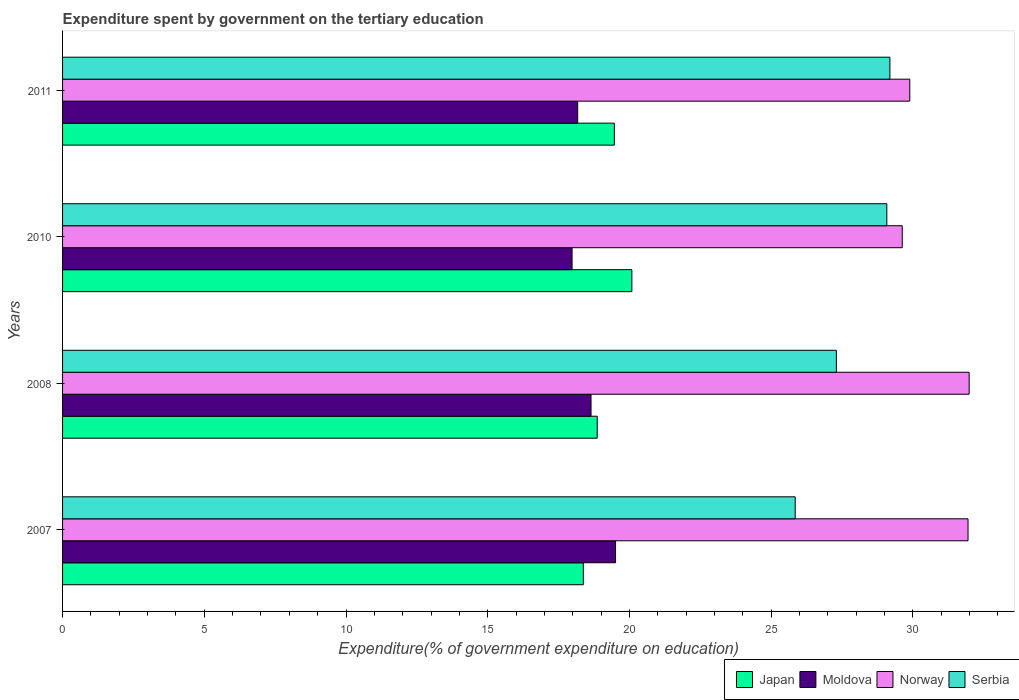How many different coloured bars are there?
Keep it short and to the point. 4. How many groups of bars are there?
Give a very brief answer. 4. Are the number of bars on each tick of the Y-axis equal?
Make the answer very short. Yes. In how many cases, is the number of bars for a given year not equal to the number of legend labels?
Your response must be concise. 0. What is the expenditure spent by government on the tertiary education in Norway in 2011?
Offer a very short reply. 29.89. Across all years, what is the maximum expenditure spent by government on the tertiary education in Norway?
Make the answer very short. 31.99. Across all years, what is the minimum expenditure spent by government on the tertiary education in Serbia?
Offer a very short reply. 25.85. In which year was the expenditure spent by government on the tertiary education in Moldova maximum?
Offer a terse response. 2007. In which year was the expenditure spent by government on the tertiary education in Japan minimum?
Your answer should be compact. 2007. What is the total expenditure spent by government on the tertiary education in Norway in the graph?
Keep it short and to the point. 123.45. What is the difference between the expenditure spent by government on the tertiary education in Norway in 2007 and that in 2010?
Keep it short and to the point. 2.32. What is the difference between the expenditure spent by government on the tertiary education in Moldova in 2011 and the expenditure spent by government on the tertiary education in Japan in 2008?
Your answer should be compact. -0.69. What is the average expenditure spent by government on the tertiary education in Norway per year?
Your response must be concise. 30.86. In the year 2010, what is the difference between the expenditure spent by government on the tertiary education in Japan and expenditure spent by government on the tertiary education in Serbia?
Your answer should be compact. -9. What is the ratio of the expenditure spent by government on the tertiary education in Serbia in 2007 to that in 2010?
Offer a very short reply. 0.89. Is the difference between the expenditure spent by government on the tertiary education in Japan in 2007 and 2011 greater than the difference between the expenditure spent by government on the tertiary education in Serbia in 2007 and 2011?
Offer a very short reply. Yes. What is the difference between the highest and the second highest expenditure spent by government on the tertiary education in Serbia?
Offer a terse response. 0.11. What is the difference between the highest and the lowest expenditure spent by government on the tertiary education in Norway?
Provide a short and direct response. 2.36. Is the sum of the expenditure spent by government on the tertiary education in Norway in 2008 and 2011 greater than the maximum expenditure spent by government on the tertiary education in Serbia across all years?
Give a very brief answer. Yes. Is it the case that in every year, the sum of the expenditure spent by government on the tertiary education in Serbia and expenditure spent by government on the tertiary education in Moldova is greater than the sum of expenditure spent by government on the tertiary education in Japan and expenditure spent by government on the tertiary education in Norway?
Offer a very short reply. No. What does the 2nd bar from the top in 2010 represents?
Offer a very short reply. Norway. Is it the case that in every year, the sum of the expenditure spent by government on the tertiary education in Norway and expenditure spent by government on the tertiary education in Moldova is greater than the expenditure spent by government on the tertiary education in Japan?
Provide a short and direct response. Yes. Are the values on the major ticks of X-axis written in scientific E-notation?
Give a very brief answer. No. How many legend labels are there?
Offer a terse response. 4. How are the legend labels stacked?
Keep it short and to the point. Horizontal. What is the title of the graph?
Your answer should be compact. Expenditure spent by government on the tertiary education. What is the label or title of the X-axis?
Offer a terse response. Expenditure(% of government expenditure on education). What is the Expenditure(% of government expenditure on education) of Japan in 2007?
Provide a succinct answer. 18.37. What is the Expenditure(% of government expenditure on education) in Moldova in 2007?
Provide a succinct answer. 19.51. What is the Expenditure(% of government expenditure on education) of Norway in 2007?
Make the answer very short. 31.95. What is the Expenditure(% of government expenditure on education) in Serbia in 2007?
Make the answer very short. 25.85. What is the Expenditure(% of government expenditure on education) in Japan in 2008?
Ensure brevity in your answer.  18.86. What is the Expenditure(% of government expenditure on education) in Moldova in 2008?
Offer a very short reply. 18.65. What is the Expenditure(% of government expenditure on education) in Norway in 2008?
Your answer should be compact. 31.99. What is the Expenditure(% of government expenditure on education) in Serbia in 2008?
Ensure brevity in your answer.  27.3. What is the Expenditure(% of government expenditure on education) of Japan in 2010?
Your answer should be very brief. 20.09. What is the Expenditure(% of government expenditure on education) in Moldova in 2010?
Offer a very short reply. 17.98. What is the Expenditure(% of government expenditure on education) in Norway in 2010?
Provide a short and direct response. 29.63. What is the Expenditure(% of government expenditure on education) in Serbia in 2010?
Keep it short and to the point. 29.08. What is the Expenditure(% of government expenditure on education) in Japan in 2011?
Your response must be concise. 19.47. What is the Expenditure(% of government expenditure on education) of Moldova in 2011?
Ensure brevity in your answer.  18.17. What is the Expenditure(% of government expenditure on education) of Norway in 2011?
Your answer should be very brief. 29.89. What is the Expenditure(% of government expenditure on education) in Serbia in 2011?
Offer a terse response. 29.19. Across all years, what is the maximum Expenditure(% of government expenditure on education) of Japan?
Offer a very short reply. 20.09. Across all years, what is the maximum Expenditure(% of government expenditure on education) in Moldova?
Offer a terse response. 19.51. Across all years, what is the maximum Expenditure(% of government expenditure on education) of Norway?
Provide a short and direct response. 31.99. Across all years, what is the maximum Expenditure(% of government expenditure on education) in Serbia?
Keep it short and to the point. 29.19. Across all years, what is the minimum Expenditure(% of government expenditure on education) of Japan?
Your answer should be very brief. 18.37. Across all years, what is the minimum Expenditure(% of government expenditure on education) of Moldova?
Ensure brevity in your answer.  17.98. Across all years, what is the minimum Expenditure(% of government expenditure on education) of Norway?
Give a very brief answer. 29.63. Across all years, what is the minimum Expenditure(% of government expenditure on education) in Serbia?
Your answer should be compact. 25.85. What is the total Expenditure(% of government expenditure on education) of Japan in the graph?
Ensure brevity in your answer.  76.79. What is the total Expenditure(% of government expenditure on education) in Moldova in the graph?
Provide a succinct answer. 74.31. What is the total Expenditure(% of government expenditure on education) in Norway in the graph?
Offer a very short reply. 123.45. What is the total Expenditure(% of government expenditure on education) in Serbia in the graph?
Provide a succinct answer. 111.42. What is the difference between the Expenditure(% of government expenditure on education) in Japan in 2007 and that in 2008?
Provide a succinct answer. -0.49. What is the difference between the Expenditure(% of government expenditure on education) of Moldova in 2007 and that in 2008?
Provide a short and direct response. 0.86. What is the difference between the Expenditure(% of government expenditure on education) in Norway in 2007 and that in 2008?
Your answer should be very brief. -0.04. What is the difference between the Expenditure(% of government expenditure on education) in Serbia in 2007 and that in 2008?
Provide a succinct answer. -1.45. What is the difference between the Expenditure(% of government expenditure on education) of Japan in 2007 and that in 2010?
Offer a very short reply. -1.71. What is the difference between the Expenditure(% of government expenditure on education) of Moldova in 2007 and that in 2010?
Keep it short and to the point. 1.53. What is the difference between the Expenditure(% of government expenditure on education) in Norway in 2007 and that in 2010?
Your answer should be very brief. 2.32. What is the difference between the Expenditure(% of government expenditure on education) of Serbia in 2007 and that in 2010?
Keep it short and to the point. -3.23. What is the difference between the Expenditure(% of government expenditure on education) of Japan in 2007 and that in 2011?
Give a very brief answer. -1.1. What is the difference between the Expenditure(% of government expenditure on education) in Moldova in 2007 and that in 2011?
Your answer should be very brief. 1.34. What is the difference between the Expenditure(% of government expenditure on education) of Norway in 2007 and that in 2011?
Keep it short and to the point. 2.06. What is the difference between the Expenditure(% of government expenditure on education) in Serbia in 2007 and that in 2011?
Give a very brief answer. -3.34. What is the difference between the Expenditure(% of government expenditure on education) of Japan in 2008 and that in 2010?
Your answer should be compact. -1.22. What is the difference between the Expenditure(% of government expenditure on education) of Moldova in 2008 and that in 2010?
Make the answer very short. 0.67. What is the difference between the Expenditure(% of government expenditure on education) of Norway in 2008 and that in 2010?
Your answer should be compact. 2.36. What is the difference between the Expenditure(% of government expenditure on education) in Serbia in 2008 and that in 2010?
Ensure brevity in your answer.  -1.78. What is the difference between the Expenditure(% of government expenditure on education) in Japan in 2008 and that in 2011?
Make the answer very short. -0.6. What is the difference between the Expenditure(% of government expenditure on education) in Moldova in 2008 and that in 2011?
Make the answer very short. 0.47. What is the difference between the Expenditure(% of government expenditure on education) of Norway in 2008 and that in 2011?
Offer a very short reply. 2.1. What is the difference between the Expenditure(% of government expenditure on education) in Serbia in 2008 and that in 2011?
Make the answer very short. -1.89. What is the difference between the Expenditure(% of government expenditure on education) in Japan in 2010 and that in 2011?
Give a very brief answer. 0.62. What is the difference between the Expenditure(% of government expenditure on education) of Moldova in 2010 and that in 2011?
Give a very brief answer. -0.2. What is the difference between the Expenditure(% of government expenditure on education) in Norway in 2010 and that in 2011?
Your response must be concise. -0.27. What is the difference between the Expenditure(% of government expenditure on education) of Serbia in 2010 and that in 2011?
Offer a very short reply. -0.11. What is the difference between the Expenditure(% of government expenditure on education) of Japan in 2007 and the Expenditure(% of government expenditure on education) of Moldova in 2008?
Provide a short and direct response. -0.27. What is the difference between the Expenditure(% of government expenditure on education) in Japan in 2007 and the Expenditure(% of government expenditure on education) in Norway in 2008?
Give a very brief answer. -13.61. What is the difference between the Expenditure(% of government expenditure on education) of Japan in 2007 and the Expenditure(% of government expenditure on education) of Serbia in 2008?
Your response must be concise. -8.93. What is the difference between the Expenditure(% of government expenditure on education) of Moldova in 2007 and the Expenditure(% of government expenditure on education) of Norway in 2008?
Your answer should be very brief. -12.48. What is the difference between the Expenditure(% of government expenditure on education) of Moldova in 2007 and the Expenditure(% of government expenditure on education) of Serbia in 2008?
Keep it short and to the point. -7.79. What is the difference between the Expenditure(% of government expenditure on education) in Norway in 2007 and the Expenditure(% of government expenditure on education) in Serbia in 2008?
Provide a short and direct response. 4.65. What is the difference between the Expenditure(% of government expenditure on education) in Japan in 2007 and the Expenditure(% of government expenditure on education) in Moldova in 2010?
Keep it short and to the point. 0.4. What is the difference between the Expenditure(% of government expenditure on education) in Japan in 2007 and the Expenditure(% of government expenditure on education) in Norway in 2010?
Make the answer very short. -11.25. What is the difference between the Expenditure(% of government expenditure on education) in Japan in 2007 and the Expenditure(% of government expenditure on education) in Serbia in 2010?
Your response must be concise. -10.71. What is the difference between the Expenditure(% of government expenditure on education) in Moldova in 2007 and the Expenditure(% of government expenditure on education) in Norway in 2010?
Ensure brevity in your answer.  -10.12. What is the difference between the Expenditure(% of government expenditure on education) in Moldova in 2007 and the Expenditure(% of government expenditure on education) in Serbia in 2010?
Make the answer very short. -9.57. What is the difference between the Expenditure(% of government expenditure on education) of Norway in 2007 and the Expenditure(% of government expenditure on education) of Serbia in 2010?
Offer a very short reply. 2.87. What is the difference between the Expenditure(% of government expenditure on education) of Japan in 2007 and the Expenditure(% of government expenditure on education) of Moldova in 2011?
Offer a very short reply. 0.2. What is the difference between the Expenditure(% of government expenditure on education) of Japan in 2007 and the Expenditure(% of government expenditure on education) of Norway in 2011?
Offer a very short reply. -11.52. What is the difference between the Expenditure(% of government expenditure on education) of Japan in 2007 and the Expenditure(% of government expenditure on education) of Serbia in 2011?
Your response must be concise. -10.82. What is the difference between the Expenditure(% of government expenditure on education) in Moldova in 2007 and the Expenditure(% of government expenditure on education) in Norway in 2011?
Provide a short and direct response. -10.38. What is the difference between the Expenditure(% of government expenditure on education) in Moldova in 2007 and the Expenditure(% of government expenditure on education) in Serbia in 2011?
Keep it short and to the point. -9.68. What is the difference between the Expenditure(% of government expenditure on education) in Norway in 2007 and the Expenditure(% of government expenditure on education) in Serbia in 2011?
Provide a short and direct response. 2.76. What is the difference between the Expenditure(% of government expenditure on education) of Japan in 2008 and the Expenditure(% of government expenditure on education) of Moldova in 2010?
Offer a terse response. 0.89. What is the difference between the Expenditure(% of government expenditure on education) of Japan in 2008 and the Expenditure(% of government expenditure on education) of Norway in 2010?
Provide a short and direct response. -10.76. What is the difference between the Expenditure(% of government expenditure on education) in Japan in 2008 and the Expenditure(% of government expenditure on education) in Serbia in 2010?
Make the answer very short. -10.22. What is the difference between the Expenditure(% of government expenditure on education) in Moldova in 2008 and the Expenditure(% of government expenditure on education) in Norway in 2010?
Provide a short and direct response. -10.98. What is the difference between the Expenditure(% of government expenditure on education) of Moldova in 2008 and the Expenditure(% of government expenditure on education) of Serbia in 2010?
Your answer should be very brief. -10.44. What is the difference between the Expenditure(% of government expenditure on education) of Norway in 2008 and the Expenditure(% of government expenditure on education) of Serbia in 2010?
Your answer should be very brief. 2.9. What is the difference between the Expenditure(% of government expenditure on education) in Japan in 2008 and the Expenditure(% of government expenditure on education) in Moldova in 2011?
Give a very brief answer. 0.69. What is the difference between the Expenditure(% of government expenditure on education) in Japan in 2008 and the Expenditure(% of government expenditure on education) in Norway in 2011?
Your response must be concise. -11.03. What is the difference between the Expenditure(% of government expenditure on education) in Japan in 2008 and the Expenditure(% of government expenditure on education) in Serbia in 2011?
Give a very brief answer. -10.33. What is the difference between the Expenditure(% of government expenditure on education) in Moldova in 2008 and the Expenditure(% of government expenditure on education) in Norway in 2011?
Ensure brevity in your answer.  -11.25. What is the difference between the Expenditure(% of government expenditure on education) of Moldova in 2008 and the Expenditure(% of government expenditure on education) of Serbia in 2011?
Offer a very short reply. -10.55. What is the difference between the Expenditure(% of government expenditure on education) in Norway in 2008 and the Expenditure(% of government expenditure on education) in Serbia in 2011?
Your answer should be compact. 2.8. What is the difference between the Expenditure(% of government expenditure on education) in Japan in 2010 and the Expenditure(% of government expenditure on education) in Moldova in 2011?
Your answer should be very brief. 1.91. What is the difference between the Expenditure(% of government expenditure on education) in Japan in 2010 and the Expenditure(% of government expenditure on education) in Norway in 2011?
Offer a terse response. -9.81. What is the difference between the Expenditure(% of government expenditure on education) in Japan in 2010 and the Expenditure(% of government expenditure on education) in Serbia in 2011?
Provide a short and direct response. -9.1. What is the difference between the Expenditure(% of government expenditure on education) in Moldova in 2010 and the Expenditure(% of government expenditure on education) in Norway in 2011?
Provide a succinct answer. -11.92. What is the difference between the Expenditure(% of government expenditure on education) in Moldova in 2010 and the Expenditure(% of government expenditure on education) in Serbia in 2011?
Give a very brief answer. -11.21. What is the difference between the Expenditure(% of government expenditure on education) of Norway in 2010 and the Expenditure(% of government expenditure on education) of Serbia in 2011?
Give a very brief answer. 0.44. What is the average Expenditure(% of government expenditure on education) of Japan per year?
Your answer should be compact. 19.2. What is the average Expenditure(% of government expenditure on education) in Moldova per year?
Provide a succinct answer. 18.58. What is the average Expenditure(% of government expenditure on education) in Norway per year?
Your response must be concise. 30.86. What is the average Expenditure(% of government expenditure on education) in Serbia per year?
Your answer should be compact. 27.86. In the year 2007, what is the difference between the Expenditure(% of government expenditure on education) in Japan and Expenditure(% of government expenditure on education) in Moldova?
Provide a short and direct response. -1.14. In the year 2007, what is the difference between the Expenditure(% of government expenditure on education) of Japan and Expenditure(% of government expenditure on education) of Norway?
Provide a short and direct response. -13.57. In the year 2007, what is the difference between the Expenditure(% of government expenditure on education) of Japan and Expenditure(% of government expenditure on education) of Serbia?
Offer a very short reply. -7.48. In the year 2007, what is the difference between the Expenditure(% of government expenditure on education) in Moldova and Expenditure(% of government expenditure on education) in Norway?
Your answer should be compact. -12.44. In the year 2007, what is the difference between the Expenditure(% of government expenditure on education) in Moldova and Expenditure(% of government expenditure on education) in Serbia?
Provide a succinct answer. -6.34. In the year 2007, what is the difference between the Expenditure(% of government expenditure on education) of Norway and Expenditure(% of government expenditure on education) of Serbia?
Your answer should be compact. 6.1. In the year 2008, what is the difference between the Expenditure(% of government expenditure on education) of Japan and Expenditure(% of government expenditure on education) of Moldova?
Provide a short and direct response. 0.22. In the year 2008, what is the difference between the Expenditure(% of government expenditure on education) of Japan and Expenditure(% of government expenditure on education) of Norway?
Provide a short and direct response. -13.12. In the year 2008, what is the difference between the Expenditure(% of government expenditure on education) of Japan and Expenditure(% of government expenditure on education) of Serbia?
Your answer should be compact. -8.44. In the year 2008, what is the difference between the Expenditure(% of government expenditure on education) of Moldova and Expenditure(% of government expenditure on education) of Norway?
Your response must be concise. -13.34. In the year 2008, what is the difference between the Expenditure(% of government expenditure on education) in Moldova and Expenditure(% of government expenditure on education) in Serbia?
Provide a short and direct response. -8.66. In the year 2008, what is the difference between the Expenditure(% of government expenditure on education) of Norway and Expenditure(% of government expenditure on education) of Serbia?
Provide a short and direct response. 4.68. In the year 2010, what is the difference between the Expenditure(% of government expenditure on education) in Japan and Expenditure(% of government expenditure on education) in Moldova?
Your answer should be compact. 2.11. In the year 2010, what is the difference between the Expenditure(% of government expenditure on education) in Japan and Expenditure(% of government expenditure on education) in Norway?
Keep it short and to the point. -9.54. In the year 2010, what is the difference between the Expenditure(% of government expenditure on education) in Japan and Expenditure(% of government expenditure on education) in Serbia?
Offer a very short reply. -9. In the year 2010, what is the difference between the Expenditure(% of government expenditure on education) of Moldova and Expenditure(% of government expenditure on education) of Norway?
Keep it short and to the point. -11.65. In the year 2010, what is the difference between the Expenditure(% of government expenditure on education) of Moldova and Expenditure(% of government expenditure on education) of Serbia?
Keep it short and to the point. -11.11. In the year 2010, what is the difference between the Expenditure(% of government expenditure on education) in Norway and Expenditure(% of government expenditure on education) in Serbia?
Provide a short and direct response. 0.54. In the year 2011, what is the difference between the Expenditure(% of government expenditure on education) of Japan and Expenditure(% of government expenditure on education) of Moldova?
Provide a succinct answer. 1.29. In the year 2011, what is the difference between the Expenditure(% of government expenditure on education) of Japan and Expenditure(% of government expenditure on education) of Norway?
Your answer should be very brief. -10.42. In the year 2011, what is the difference between the Expenditure(% of government expenditure on education) in Japan and Expenditure(% of government expenditure on education) in Serbia?
Provide a succinct answer. -9.72. In the year 2011, what is the difference between the Expenditure(% of government expenditure on education) in Moldova and Expenditure(% of government expenditure on education) in Norway?
Your response must be concise. -11.72. In the year 2011, what is the difference between the Expenditure(% of government expenditure on education) in Moldova and Expenditure(% of government expenditure on education) in Serbia?
Ensure brevity in your answer.  -11.02. In the year 2011, what is the difference between the Expenditure(% of government expenditure on education) in Norway and Expenditure(% of government expenditure on education) in Serbia?
Keep it short and to the point. 0.7. What is the ratio of the Expenditure(% of government expenditure on education) in Moldova in 2007 to that in 2008?
Your answer should be compact. 1.05. What is the ratio of the Expenditure(% of government expenditure on education) of Norway in 2007 to that in 2008?
Your answer should be very brief. 1. What is the ratio of the Expenditure(% of government expenditure on education) of Serbia in 2007 to that in 2008?
Your answer should be very brief. 0.95. What is the ratio of the Expenditure(% of government expenditure on education) in Japan in 2007 to that in 2010?
Make the answer very short. 0.91. What is the ratio of the Expenditure(% of government expenditure on education) of Moldova in 2007 to that in 2010?
Ensure brevity in your answer.  1.09. What is the ratio of the Expenditure(% of government expenditure on education) in Norway in 2007 to that in 2010?
Keep it short and to the point. 1.08. What is the ratio of the Expenditure(% of government expenditure on education) of Serbia in 2007 to that in 2010?
Your response must be concise. 0.89. What is the ratio of the Expenditure(% of government expenditure on education) in Japan in 2007 to that in 2011?
Provide a succinct answer. 0.94. What is the ratio of the Expenditure(% of government expenditure on education) of Moldova in 2007 to that in 2011?
Ensure brevity in your answer.  1.07. What is the ratio of the Expenditure(% of government expenditure on education) of Norway in 2007 to that in 2011?
Your answer should be very brief. 1.07. What is the ratio of the Expenditure(% of government expenditure on education) of Serbia in 2007 to that in 2011?
Ensure brevity in your answer.  0.89. What is the ratio of the Expenditure(% of government expenditure on education) of Japan in 2008 to that in 2010?
Make the answer very short. 0.94. What is the ratio of the Expenditure(% of government expenditure on education) in Moldova in 2008 to that in 2010?
Your response must be concise. 1.04. What is the ratio of the Expenditure(% of government expenditure on education) in Norway in 2008 to that in 2010?
Provide a short and direct response. 1.08. What is the ratio of the Expenditure(% of government expenditure on education) in Serbia in 2008 to that in 2010?
Your response must be concise. 0.94. What is the ratio of the Expenditure(% of government expenditure on education) in Japan in 2008 to that in 2011?
Keep it short and to the point. 0.97. What is the ratio of the Expenditure(% of government expenditure on education) of Moldova in 2008 to that in 2011?
Give a very brief answer. 1.03. What is the ratio of the Expenditure(% of government expenditure on education) in Norway in 2008 to that in 2011?
Your response must be concise. 1.07. What is the ratio of the Expenditure(% of government expenditure on education) in Serbia in 2008 to that in 2011?
Your response must be concise. 0.94. What is the ratio of the Expenditure(% of government expenditure on education) in Japan in 2010 to that in 2011?
Provide a short and direct response. 1.03. What is the ratio of the Expenditure(% of government expenditure on education) of Moldova in 2010 to that in 2011?
Keep it short and to the point. 0.99. What is the ratio of the Expenditure(% of government expenditure on education) of Serbia in 2010 to that in 2011?
Your answer should be compact. 1. What is the difference between the highest and the second highest Expenditure(% of government expenditure on education) of Japan?
Ensure brevity in your answer.  0.62. What is the difference between the highest and the second highest Expenditure(% of government expenditure on education) in Moldova?
Provide a succinct answer. 0.86. What is the difference between the highest and the second highest Expenditure(% of government expenditure on education) of Norway?
Make the answer very short. 0.04. What is the difference between the highest and the second highest Expenditure(% of government expenditure on education) of Serbia?
Give a very brief answer. 0.11. What is the difference between the highest and the lowest Expenditure(% of government expenditure on education) of Japan?
Ensure brevity in your answer.  1.71. What is the difference between the highest and the lowest Expenditure(% of government expenditure on education) in Moldova?
Your answer should be very brief. 1.53. What is the difference between the highest and the lowest Expenditure(% of government expenditure on education) of Norway?
Provide a short and direct response. 2.36. What is the difference between the highest and the lowest Expenditure(% of government expenditure on education) of Serbia?
Give a very brief answer. 3.34. 